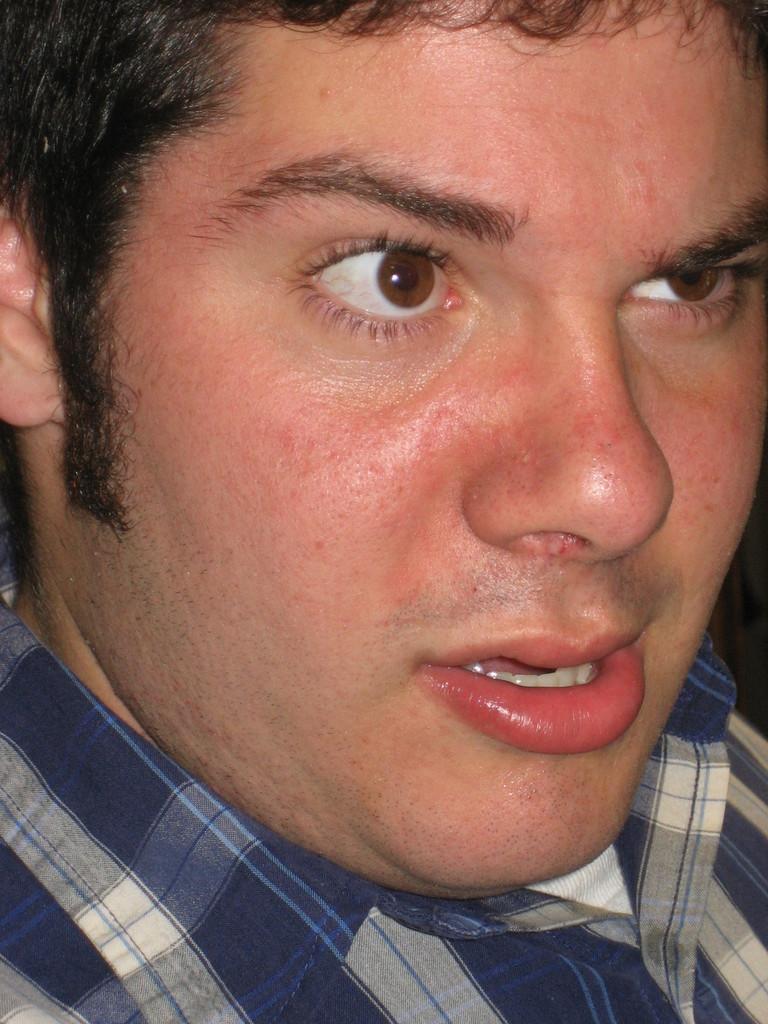Could you give a brief overview of what you see in this image? In this image there is a man he is wearing blue and white color checked shirt. 